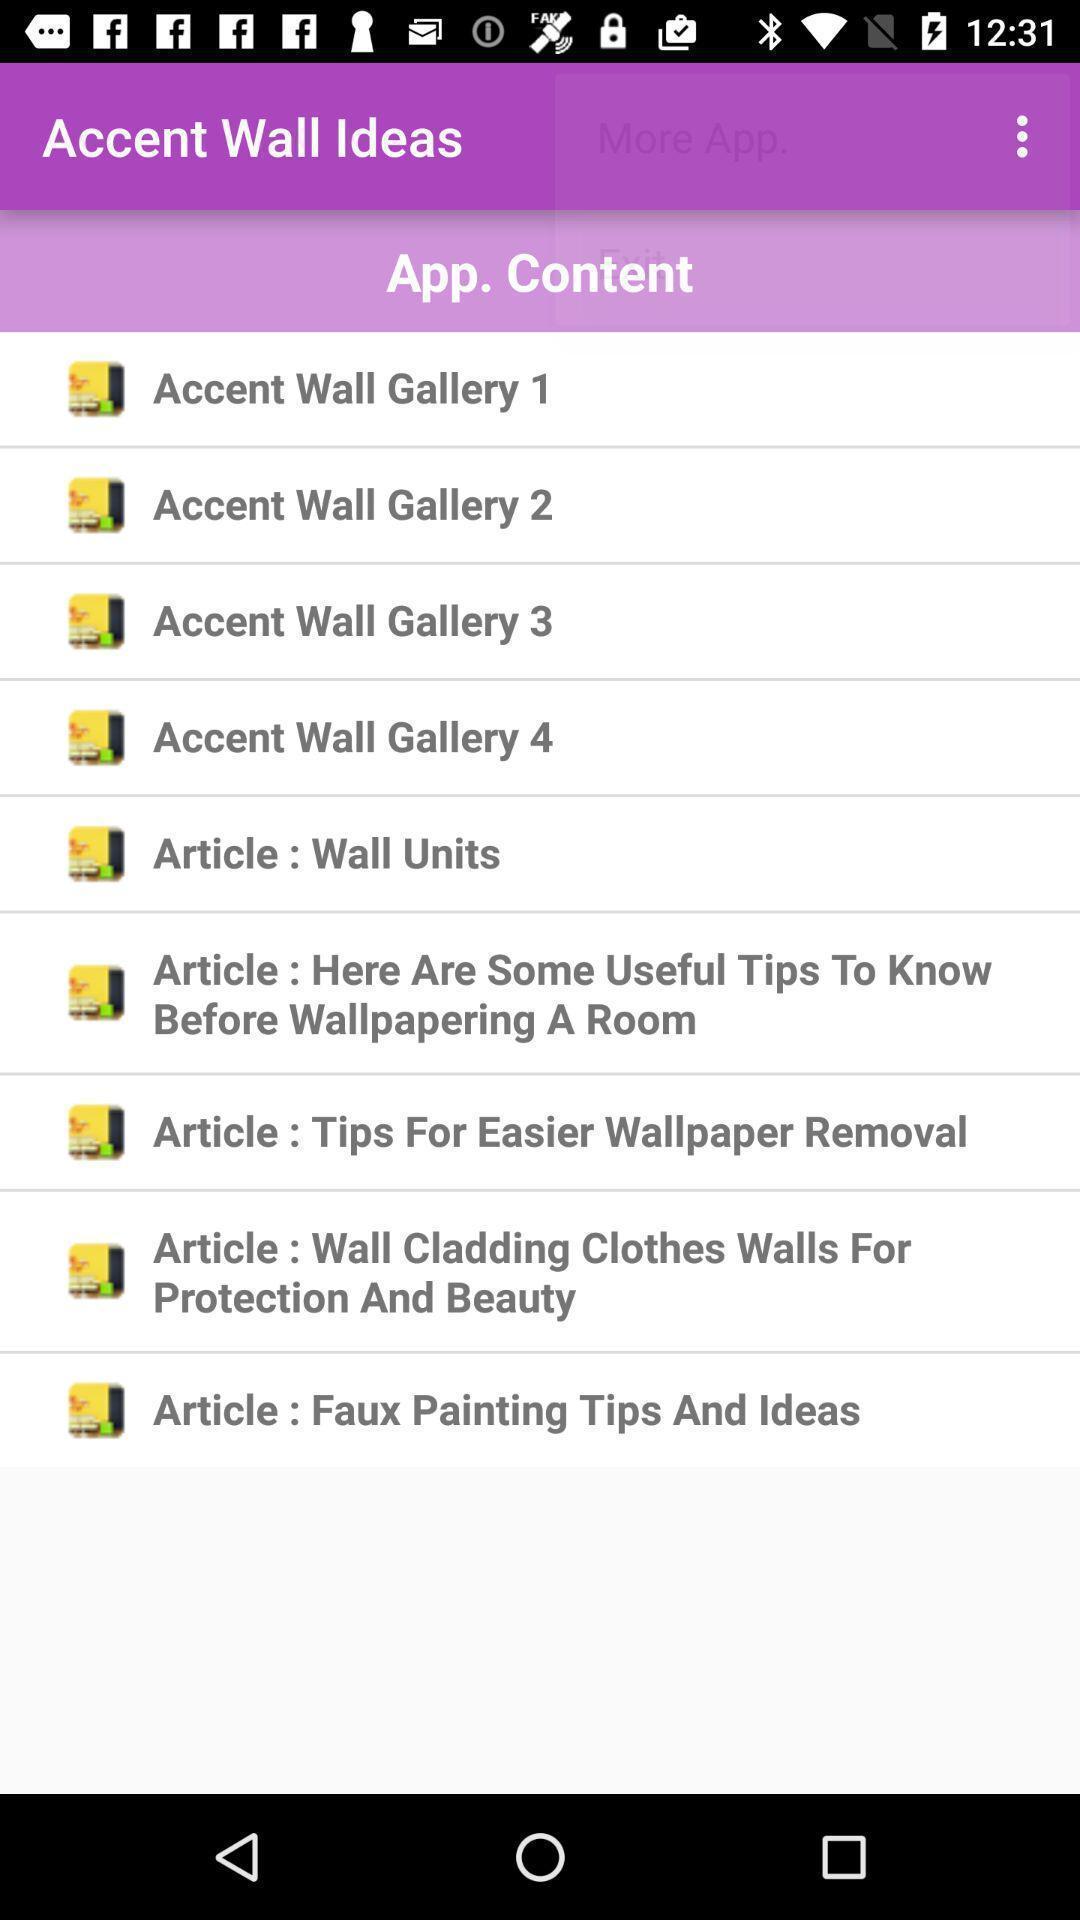Explain the elements present in this screenshot. Page showing ideas of wall decoration app. 